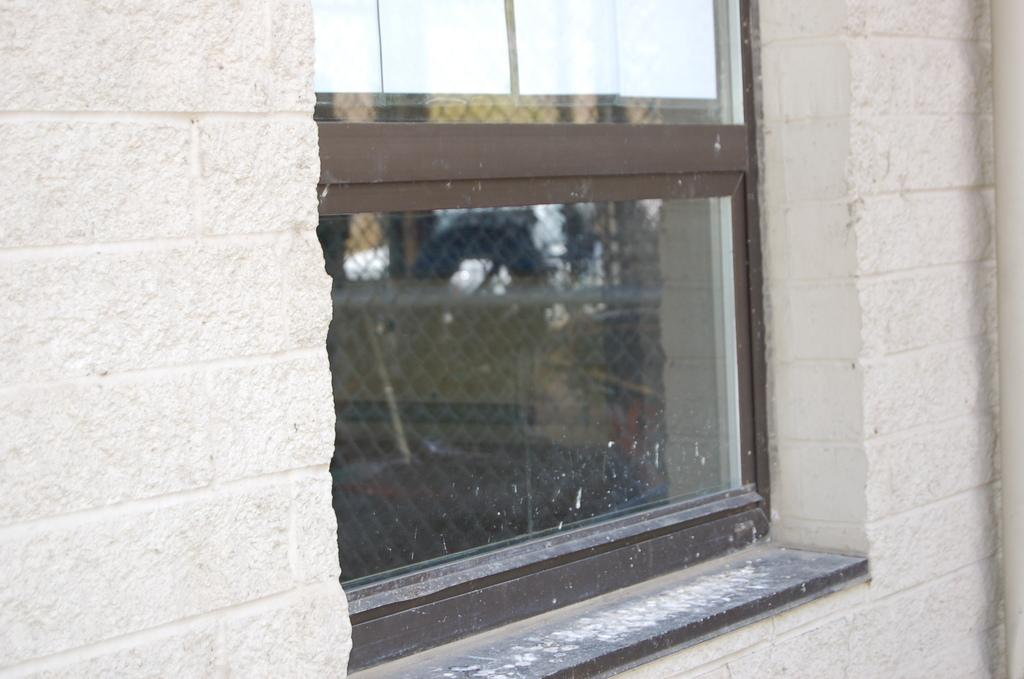What type of material is used for the windows in the image? The windows in the image are made of glass. Where are the windows located in the image? The glass windows are in the middle of the image. What else can be seen in the image besides the windows? There is a wall visible in the image. How many sheep are visible in the image? There are no sheep present in the image. What type of curve can be seen in the wall in the image? The image does not show any curves in the wall; it only shows a straight wall. 